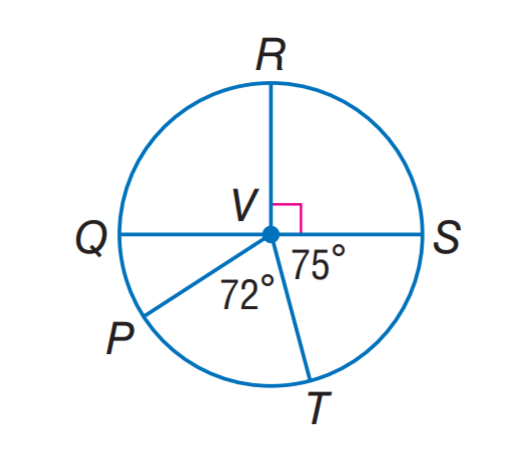Answer the mathemtical geometry problem and directly provide the correct option letter.
Question: Q S is a diameter of \odot V. Find m \widehat P Q R.
Choices: A: 123 B: 144 C: 147 D: 150 A 